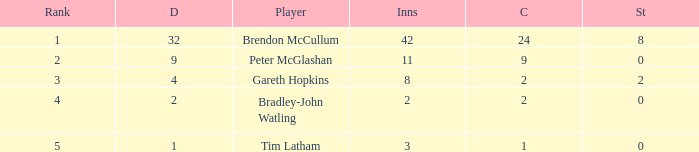How many stumpings did the player Tim Latham have? 0.0. 